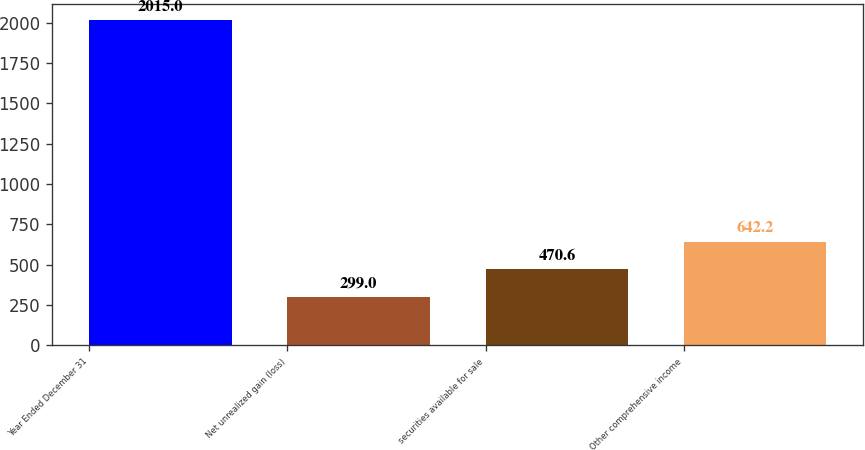Convert chart to OTSL. <chart><loc_0><loc_0><loc_500><loc_500><bar_chart><fcel>Year Ended December 31<fcel>Net unrealized gain (loss)<fcel>securities available for sale<fcel>Other comprehensive income<nl><fcel>2015<fcel>299<fcel>470.6<fcel>642.2<nl></chart> 